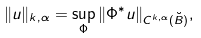<formula> <loc_0><loc_0><loc_500><loc_500>\| u \| _ { k , \alpha } = \sup _ { \Phi } \| \Phi ^ { * } u \| _ { C ^ { k , \alpha } ( \breve { B } ) } ,</formula> 